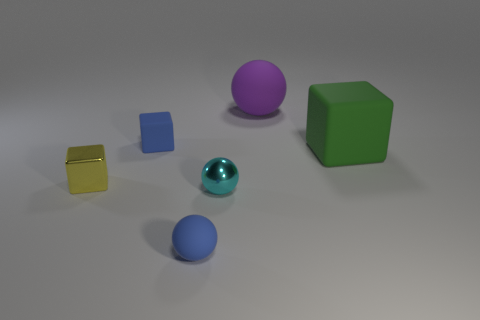There is a object that is left of the small blue rubber ball and in front of the green object; what shape is it?
Provide a succinct answer. Cube. Is the material of the small cyan object the same as the tiny blue thing behind the tiny metallic ball?
Your answer should be very brief. No. There is a large sphere; are there any tiny blue matte balls in front of it?
Keep it short and to the point. Yes. How many things are either tiny metallic objects or blocks that are behind the yellow object?
Give a very brief answer. 4. There is a tiny rubber object to the left of the blue matte object in front of the metal sphere; what color is it?
Give a very brief answer. Blue. What number of other things are there of the same material as the purple thing
Make the answer very short. 3. How many matte things are either tiny gray things or large purple spheres?
Offer a very short reply. 1. There is another big matte thing that is the same shape as the cyan object; what color is it?
Make the answer very short. Purple. What number of things are big rubber spheres or big gray rubber cylinders?
Provide a short and direct response. 1. What is the shape of the large purple thing that is the same material as the tiny blue cube?
Make the answer very short. Sphere. 